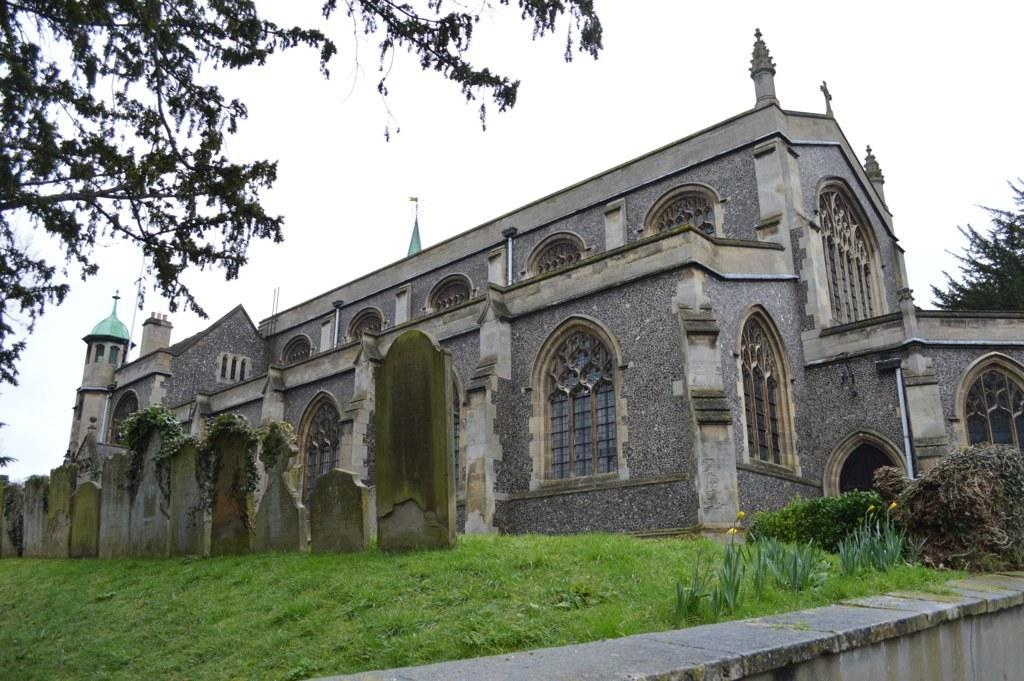What type of structure is present in the image? There is a building in the image. What is the ground covered with in the image? There is grass on the ground in the image. How many trees can be seen in the image? There are two trees in the image. What can be seen in the sky in the image? There are clouds visible in the sky in the image. What type of cord is hanging from the building in the image? There is no cord hanging from the building in the image. What nation is represented by the flag in the image? There is no flag present in the image. 